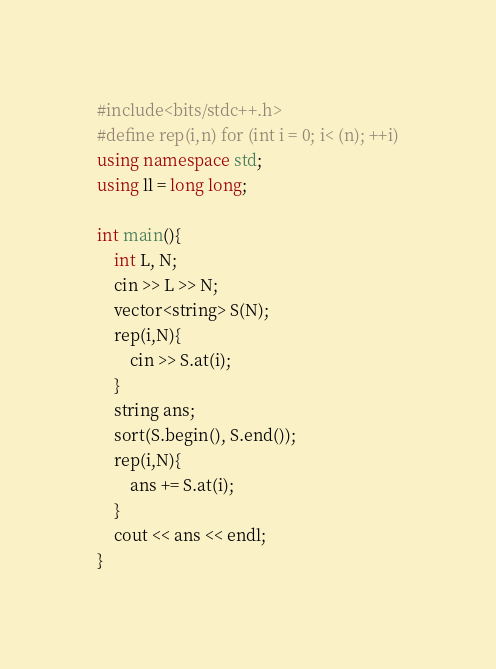Convert code to text. <code><loc_0><loc_0><loc_500><loc_500><_C++_>#include<bits/stdc++.h>
#define rep(i,n) for (int i = 0; i< (n); ++i)
using namespace std;
using ll = long long;

int main(){
    int L, N;
    cin >> L >> N;
    vector<string> S(N);
    rep(i,N){
        cin >> S.at(i);
    }
    string ans;
    sort(S.begin(), S.end());
    rep(i,N){
        ans += S.at(i);
    }
    cout << ans << endl;
}
</code> 